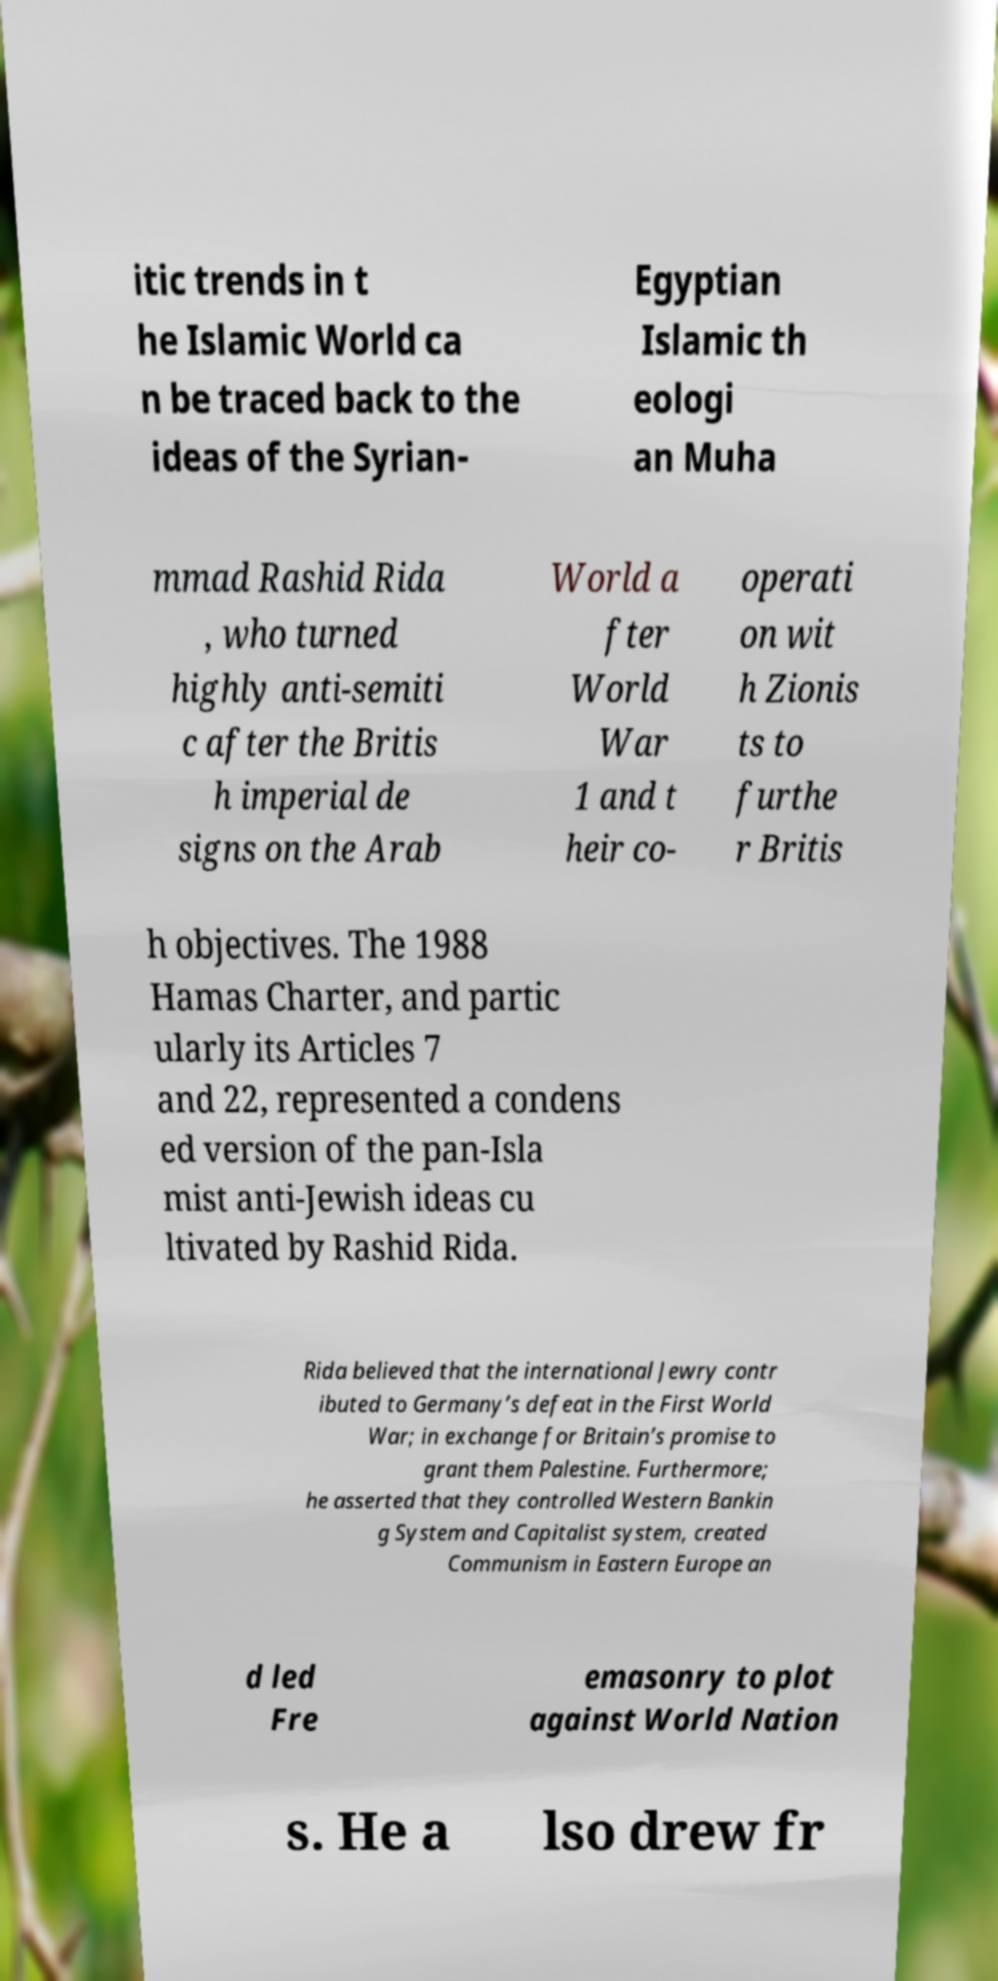There's text embedded in this image that I need extracted. Can you transcribe it verbatim? itic trends in t he Islamic World ca n be traced back to the ideas of the Syrian- Egyptian Islamic th eologi an Muha mmad Rashid Rida , who turned highly anti-semiti c after the Britis h imperial de signs on the Arab World a fter World War 1 and t heir co- operati on wit h Zionis ts to furthe r Britis h objectives. The 1988 Hamas Charter, and partic ularly its Articles 7 and 22, represented a condens ed version of the pan-Isla mist anti-Jewish ideas cu ltivated by Rashid Rida. Rida believed that the international Jewry contr ibuted to Germany’s defeat in the First World War; in exchange for Britain’s promise to grant them Palestine. Furthermore; he asserted that they controlled Western Bankin g System and Capitalist system, created Communism in Eastern Europe an d led Fre emasonry to plot against World Nation s. He a lso drew fr 